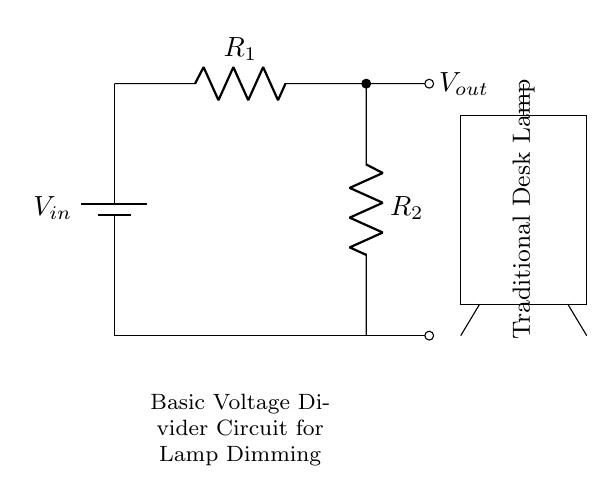What is the input voltage in this circuit? The input voltage is denoted as V_in, which represents the voltage supplied by the battery. The schematic shows a battery symbol labeled with V_in.
Answer: V_in What are the resistance values in the circuit? The circuit includes two resistors: R_1 and R_2, labeled accordingly in the diagram. The values are not specified in this context, only their identifiers are present.
Answer: R_1 and R_2 What is the output voltage of the circuit? The output voltage, V_out, can be observed at the junction between R1 and R2 as indicated by the label on the sketch. It is also the voltage available to the lamp when R1 and R2 are configured as a voltage divider.
Answer: V_out How does the output voltage relate to the resistors? The output voltage is determined by the resistor values R1 and R2 according to the voltage divider rule; specifically, V_out is equal to V_in multiplied by the fraction of R2 over the total resistance (R1 + R2). This involves understanding the division of voltage across the resistors based on their resistive values.
Answer: It is V_in multiplied by (R2 / (R1 + R2)) What type of circuit is being represented? The circuit depicted is a basic voltage divider circuit, as can be inferred from the arrangement of two resistors in series across a voltage source, illustrating how input voltage is divided to provide a lower output voltage suitable for dimming functions in the lamp.
Answer: Voltage divider circuit How can this circuit affect a lamp's brightness? The circuit allows for dimming the lamp, because as R1 and R2 change their values, the output voltage V_out varies, affecting the power delivered to the lamp. The brightness of the lamp is directly proportional to the voltage across it; hence, a lower V_out results in less brightness.
Answer: By adjusting V_out 